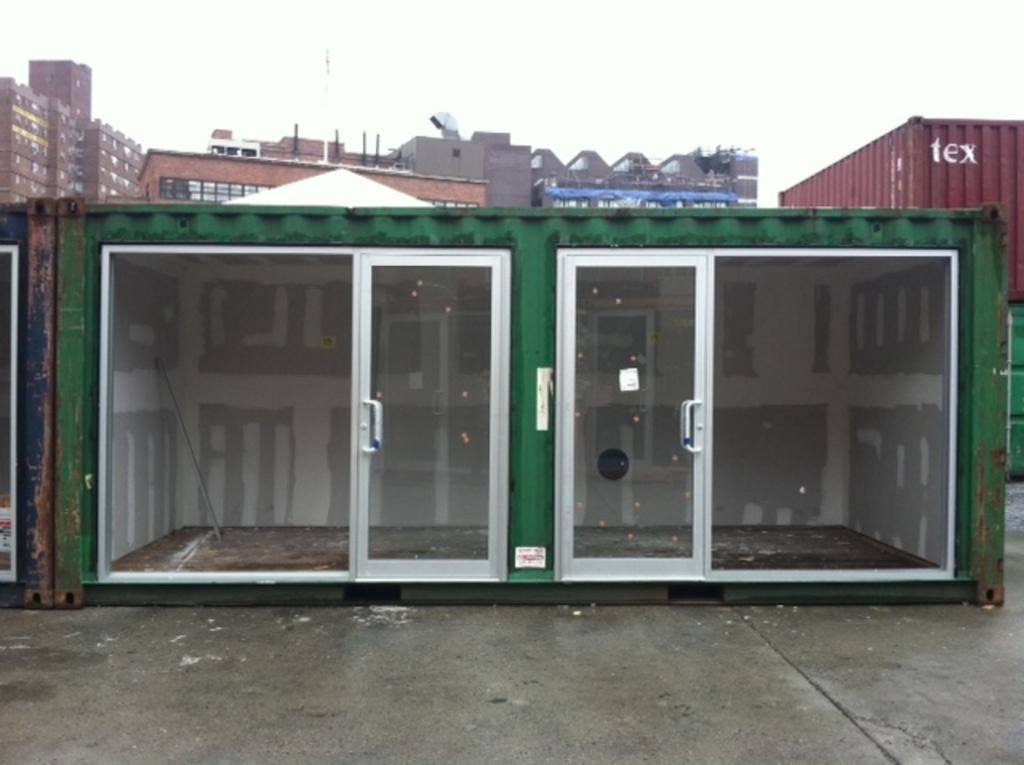What is located in the foreground of the picture? There is a shipping container with glass doors in the foreground of the picture. What can be seen on the right side of the picture? There is a container on the right side of the picture. What is visible in the background of the picture? There are buildings visible in the background of the picture. What color is the balloon floating above the shipping container in the image? There is no balloon present in the image. What fact can be learned about the development of shipping containers from the image? The image does not provide any information about the development of shipping containers. 